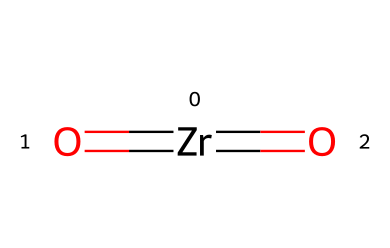How many total oxygen atoms are present in this chemical? The chemical structure shows the presence of two double-bonded oxygen atoms attached to the zirconium atom. Hence, the total count of oxygen atoms is two.
Answer: two What is the central atom in this structure? In the provided SMILES, zirconium is represented by the symbol "Zr", indicating it is the central atom in this chemical's structure.
Answer: zirconium How many bonds are shown between zirconium and oxygen? The structure indicates double bonds between zirconium and each of the two oxygen atoms; thus, there are two double bonds, making a total of two bonds.
Answer: two What type of ceramic is represented by this chemical structure? Zirconium dioxide is commonly known as zirconia, which is a highly durable ceramic used in various applications, particularly in strengthening other materials due to its toughness.
Answer: zirconia How many valence electrons does zirconium contribute to bonding in this structure? Zirconium has four valence electrons in its outer shell, which it utilizes to form covalent bonds with the two oxygen atoms shown in the structure.
Answer: four What property does the presence of zirconium dioxide impart to ceramics? Zirconium dioxide significantly enhances mechanical strength, thermal stability, and wear resistance in ceramic materials, making them more durable.
Answer: mechanical strength 